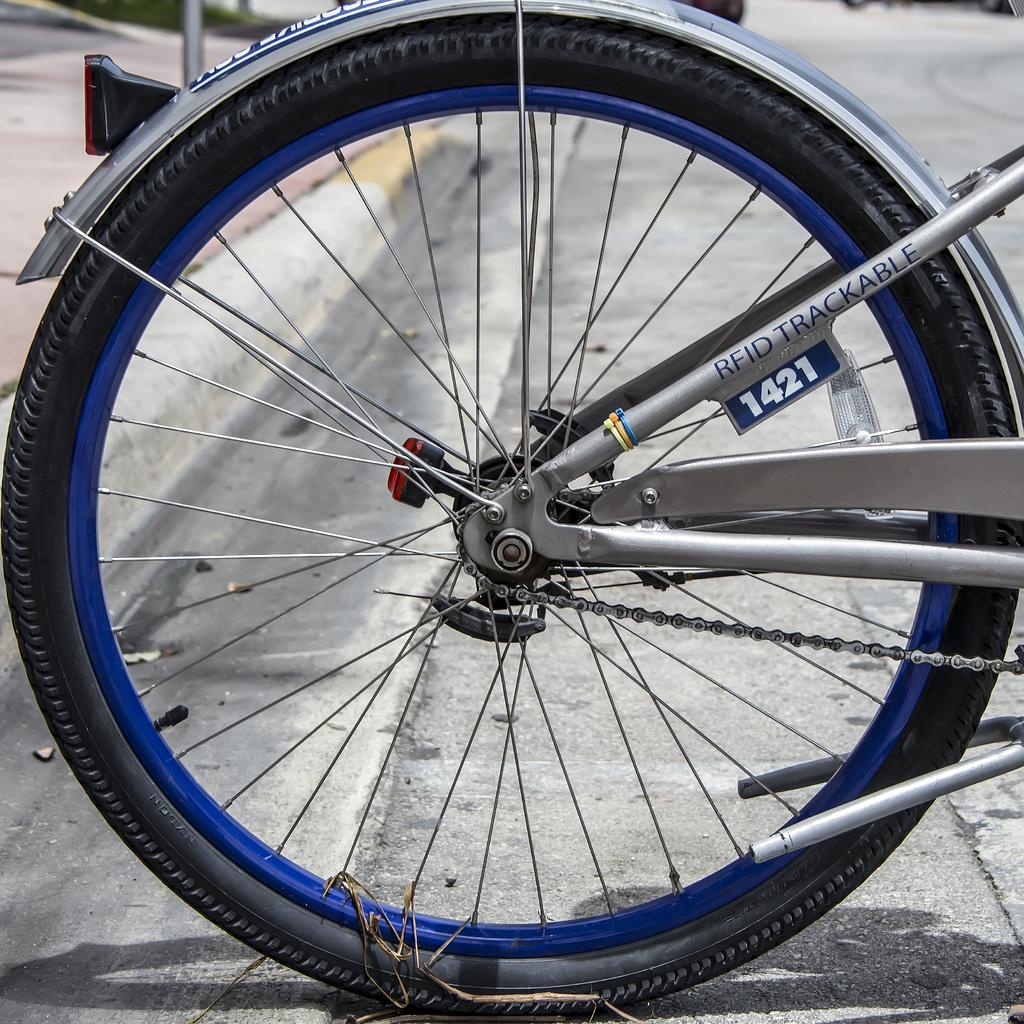What is the main subject of the image? The main subject of the image is a bicycle. What is the color of the bicycle? The bicycle is grey in color. What part of the bicycle has a different color? The rim of the bicycle is blue in color. Where is the throne located in the image? There is no throne present in the image. Can you describe the motion of the bicycle in the image? The image is a still photograph, so the bicycle is not in motion. How many rabbits can be seen hopping around the bicycle in the image? There are no rabbits present in the image. 